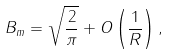<formula> <loc_0><loc_0><loc_500><loc_500>B _ { m } = \sqrt { \frac { 2 } { \pi } } + O \left ( \frac { 1 } { R } \right ) ,</formula> 